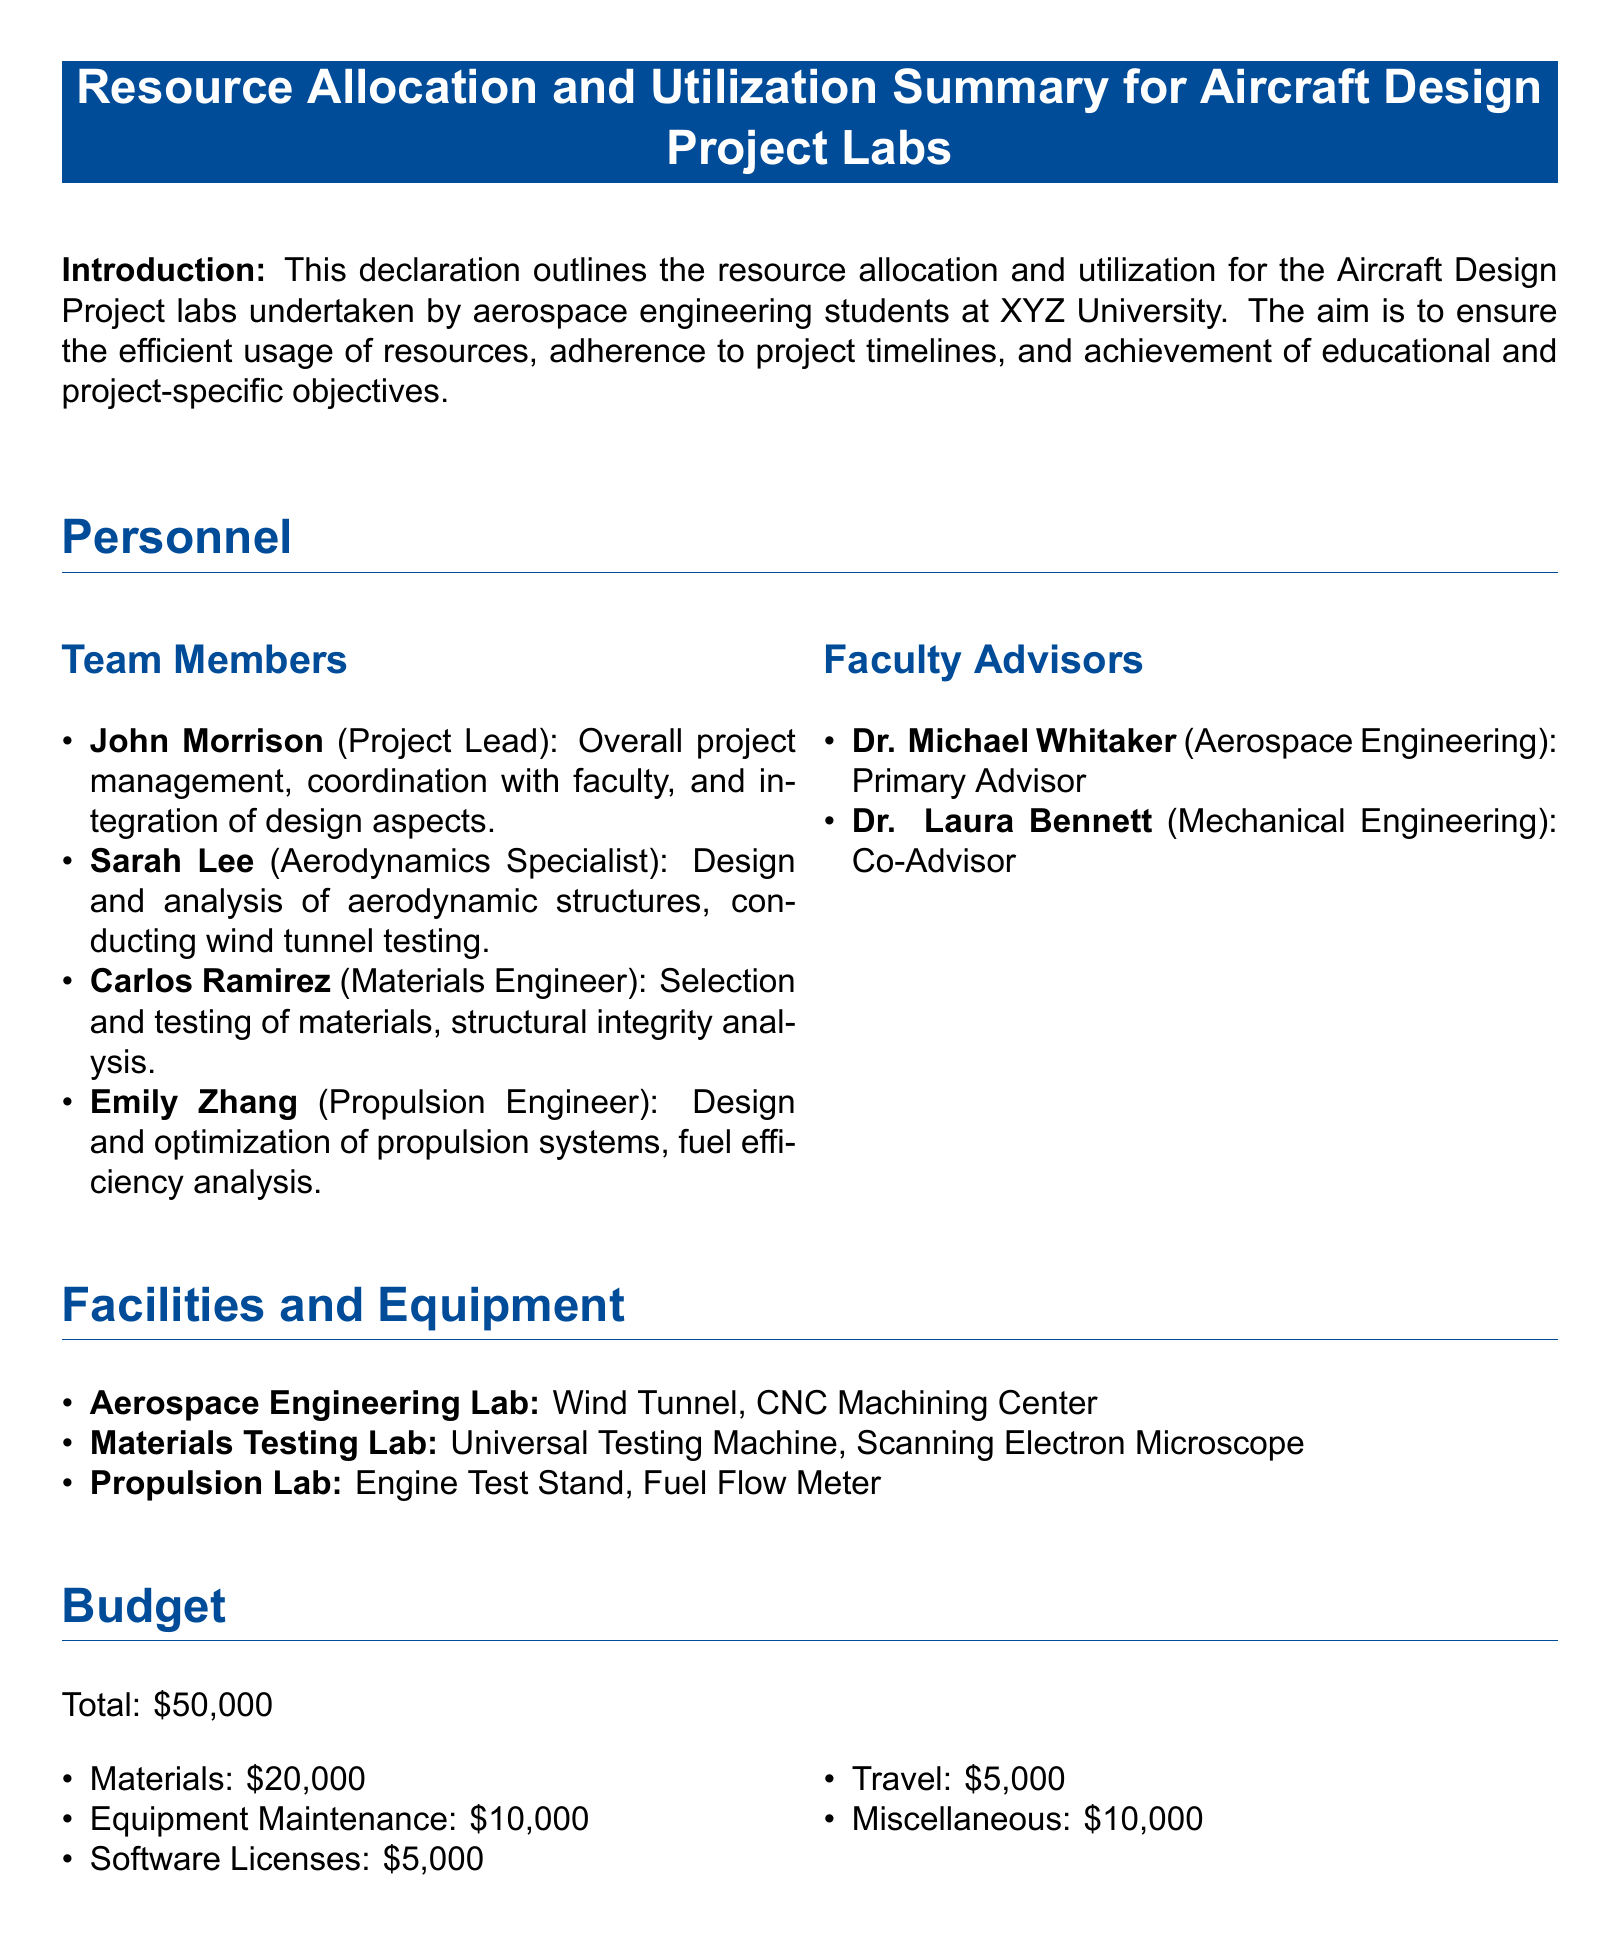What is the project budget? The total budget for the project is stated in the document, which outlines all the financial allocations.
Answer: $50,000 Who is the propulsion engineer? The document lists team members with their roles, including the propulsion engineer's name.
Answer: Emily Zhang How long is the preliminary design phase? The duration of each phase is detailed in the timeline section of the document.
Answer: 3 months What is the name of the primary advisor? The document specifies the roles of faculty advisors, including the primary advisor.
Answer: Dr. Michael Whitaker Which equipment is located in the Aerospace Engineering Lab? The facilities and equipment section lists various labs and their specific resources.
Answer: Wind Tunnel, CNC Machining Center What percentage of the budget is allocated to materials? Allocations in the budget can be converted to percentages based on the total budget amount stated.
Answer: 40% What is the total duration of the testing and evaluation phase? The timeline section provides the specific duration for the testing and evaluation phase.
Answer: 2 months Which team member is responsible for aerodynamics? The team members section specifically states the responsibilities of each individual in the project.
Answer: Sarah Lee What type of analysis does Carlos Ramirez focus on? The document outlines the role of each team member, including their specific areas of analysis and expertise.
Answer: Structural integrity analysis 